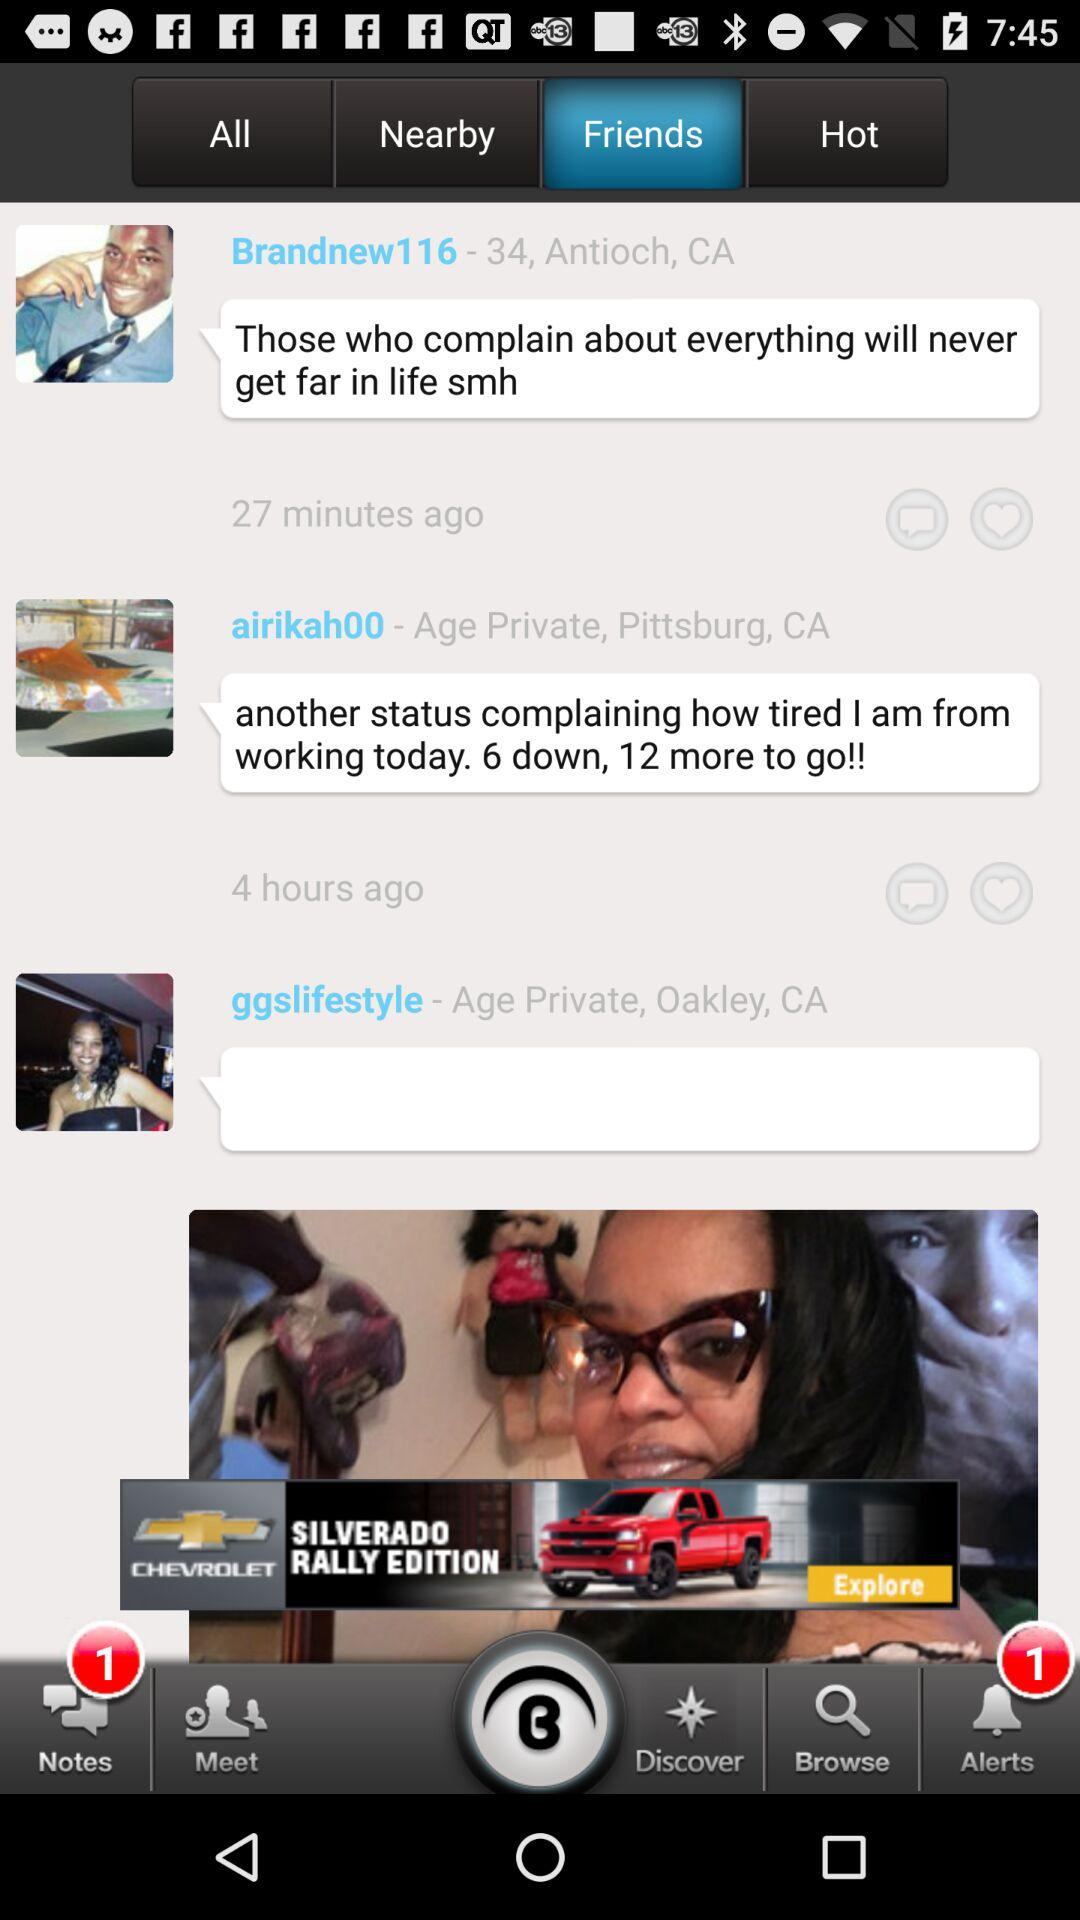What is the location of "airikah00"? The location of "airikah00" is Pittsburg, CA. 